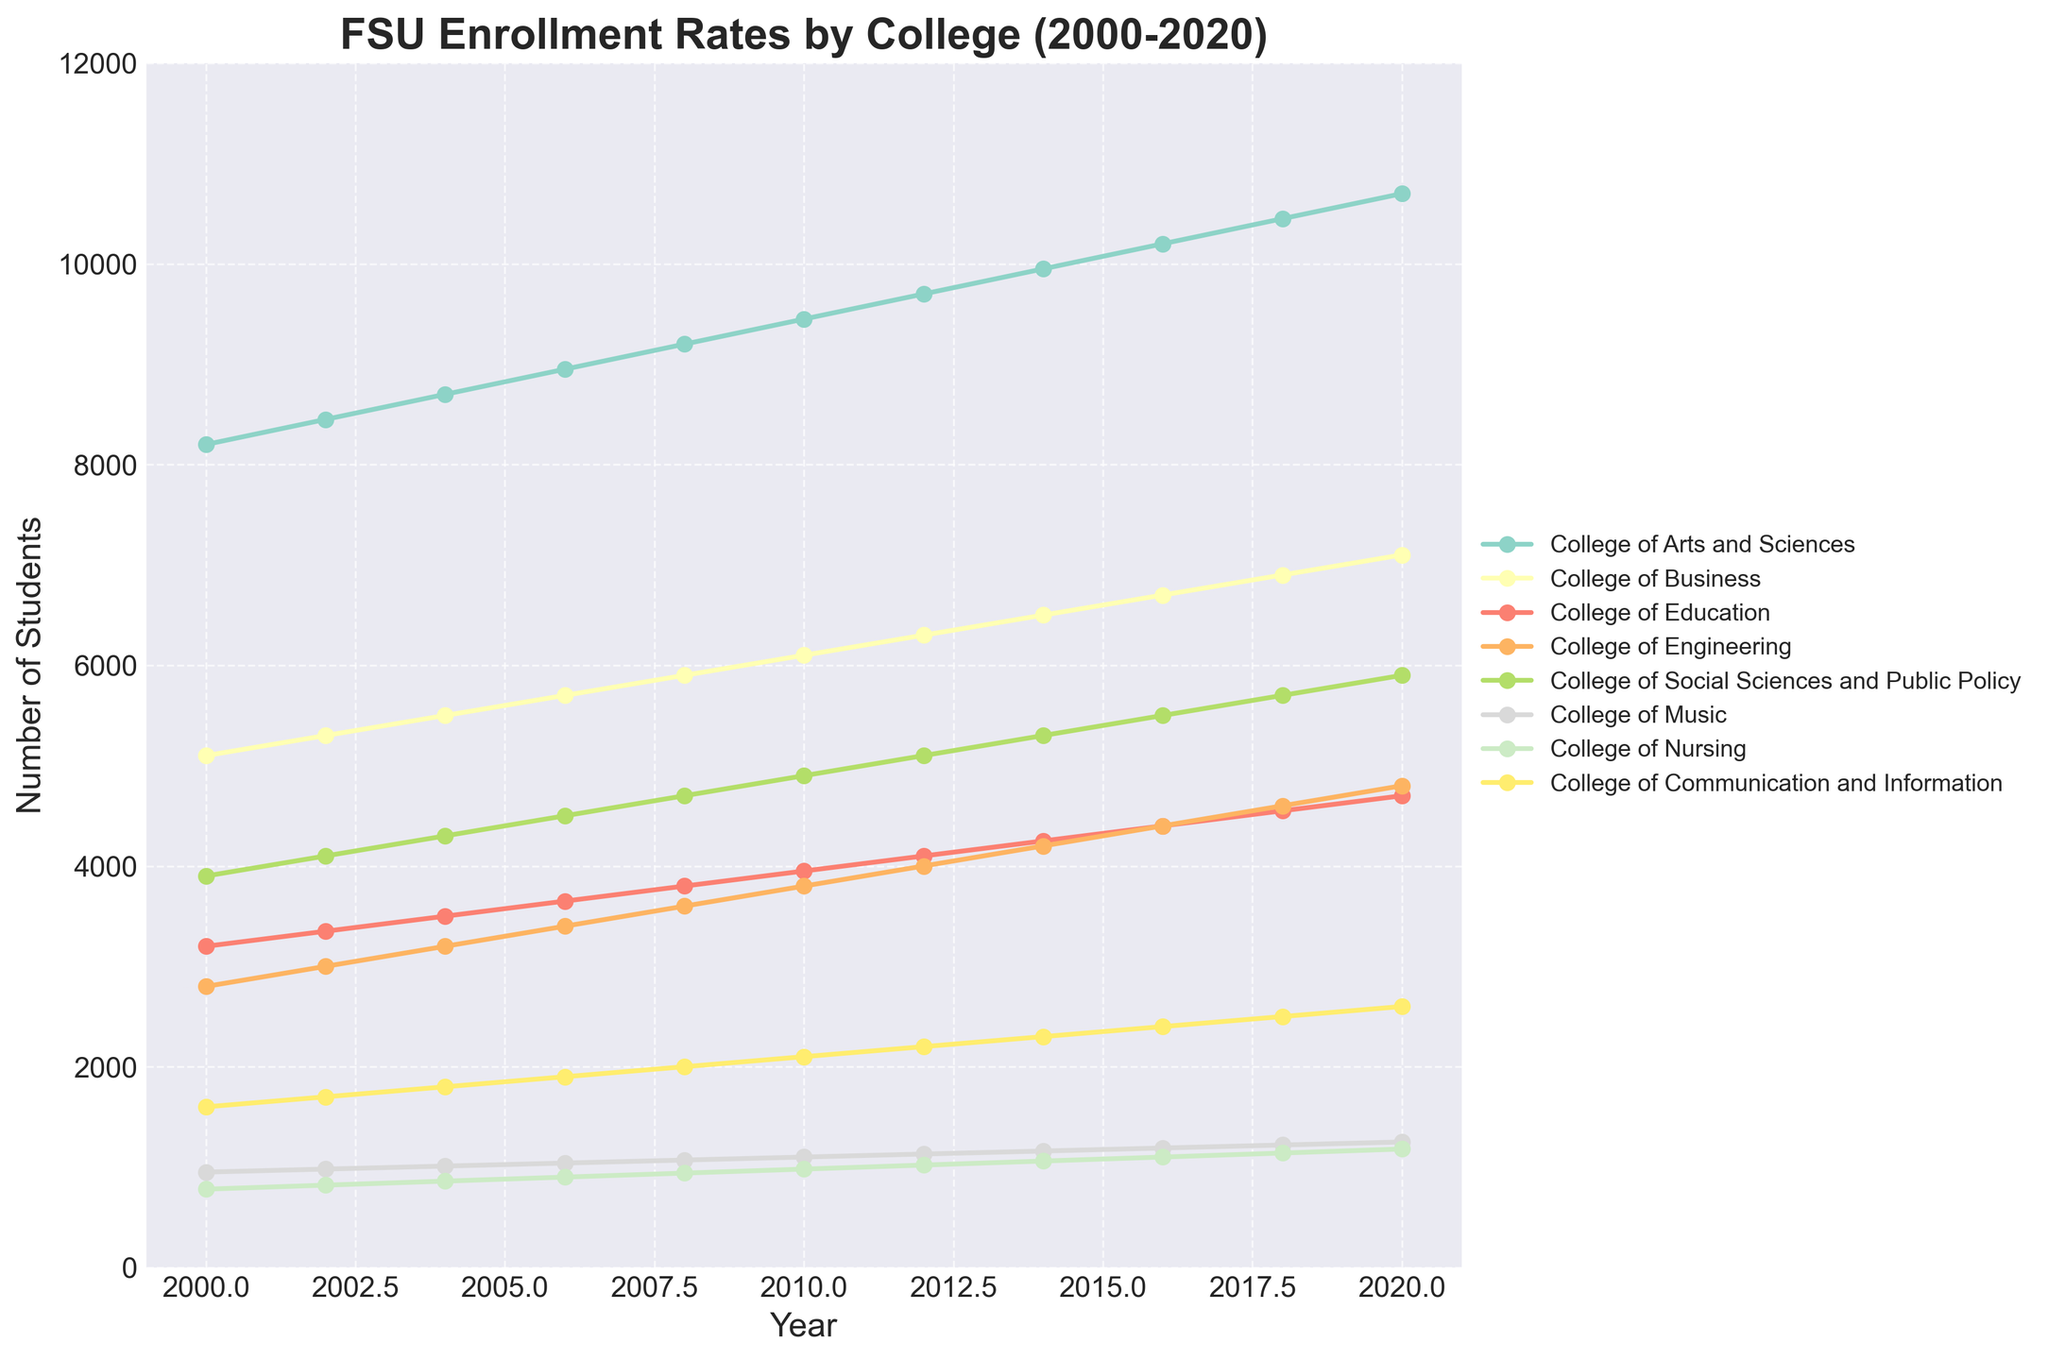Which college had the highest enrollment in 2020? Look at the y-values for the year 2020 and identify the highest one. The College of Arts and Sciences has the highest enrollment value.
Answer: College of Arts and Sciences How did enrollment in the College of Music change from 2000 to 2020? Compare the y-values for the College of Music in the year 2000 and 2020. In 2000, it was 950, and in 2020, it was 1250.
Answer: Increased by 300 Which two colleges had a similar enrollment rate in 2010? Identify the two lines that have the closest y-values in 2010. The College of Education and the College of Social Sciences and Public Policy both have enrollments close to each other in 2010.
Answer: College of Education and College of Social Sciences and Public Policy What was the average enrollment in the College of Engineering from 2000 to 2020? Calculate the sum of the y-values for the College of Engineering across all years and divide by the number of years (11 entries). The sum is 41000, and the average is 41000 / 11.
Answer: 3727.27 Did the College of Communication and Information have a consistent growth rate? Examine the slope of the line representing the College of Communication and Information over the years. The slope looks fairly consistent, indicating a nearly constant growth rate.
Answer: Yes Between 2006 and 2014, which college showed the greatest growth in enrollment? Calculate the difference in y-values between 2006 and 2014 for each college. The College of Arts and Sciences shows the largest increase (9950 - 8950 = 1000).
Answer: College of Arts and Sciences Which college had the smallest increase in enrollment from 2000 to 2020? Find the difference between the 2020 and 2000 y-values for each college and identify the smallest difference. The College of Music increased by the smallest amount (300).
Answer: College of Music Was there any year where enrollments in the College of Business exceeded those in the College of Arts and Sciences? Compare the y-values of the College of Business and the College of Arts and Sciences for each year. The College of Arts and Sciences always has higher enrollment each year.
Answer: No How much did the enrollment in the College of Nursing increase by 2016 compared to 2000? Subtract the 2000 enrollment value for the College of Nursing from the 2016 value (1100 - 780).
Answer: 320 students What was the trend of enrollment in the College of Social Sciences and Public Policy from 2000 to 2020? Analyze the line representing the College of Social Sciences and Public Policy from 2000 to 2020. The line shows a consistently increasing trend.
Answer: Consistently increasing 